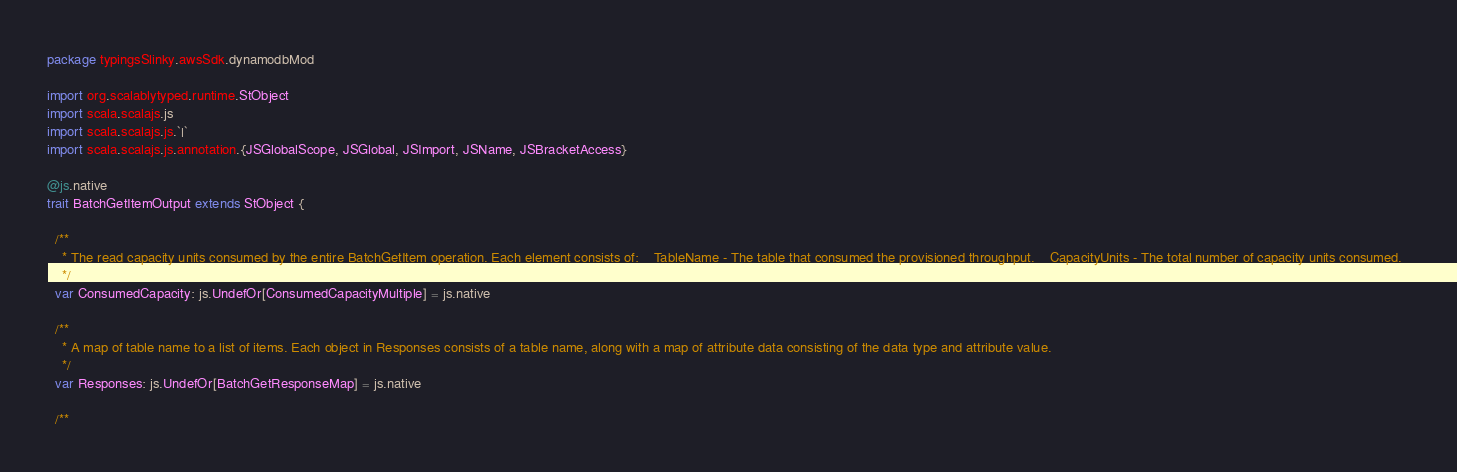<code> <loc_0><loc_0><loc_500><loc_500><_Scala_>package typingsSlinky.awsSdk.dynamodbMod

import org.scalablytyped.runtime.StObject
import scala.scalajs.js
import scala.scalajs.js.`|`
import scala.scalajs.js.annotation.{JSGlobalScope, JSGlobal, JSImport, JSName, JSBracketAccess}

@js.native
trait BatchGetItemOutput extends StObject {
  
  /**
    * The read capacity units consumed by the entire BatchGetItem operation. Each element consists of:    TableName - The table that consumed the provisioned throughput.    CapacityUnits - The total number of capacity units consumed.  
    */
  var ConsumedCapacity: js.UndefOr[ConsumedCapacityMultiple] = js.native
  
  /**
    * A map of table name to a list of items. Each object in Responses consists of a table name, along with a map of attribute data consisting of the data type and attribute value.
    */
  var Responses: js.UndefOr[BatchGetResponseMap] = js.native
  
  /**</code> 